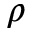<formula> <loc_0><loc_0><loc_500><loc_500>\rho</formula> 